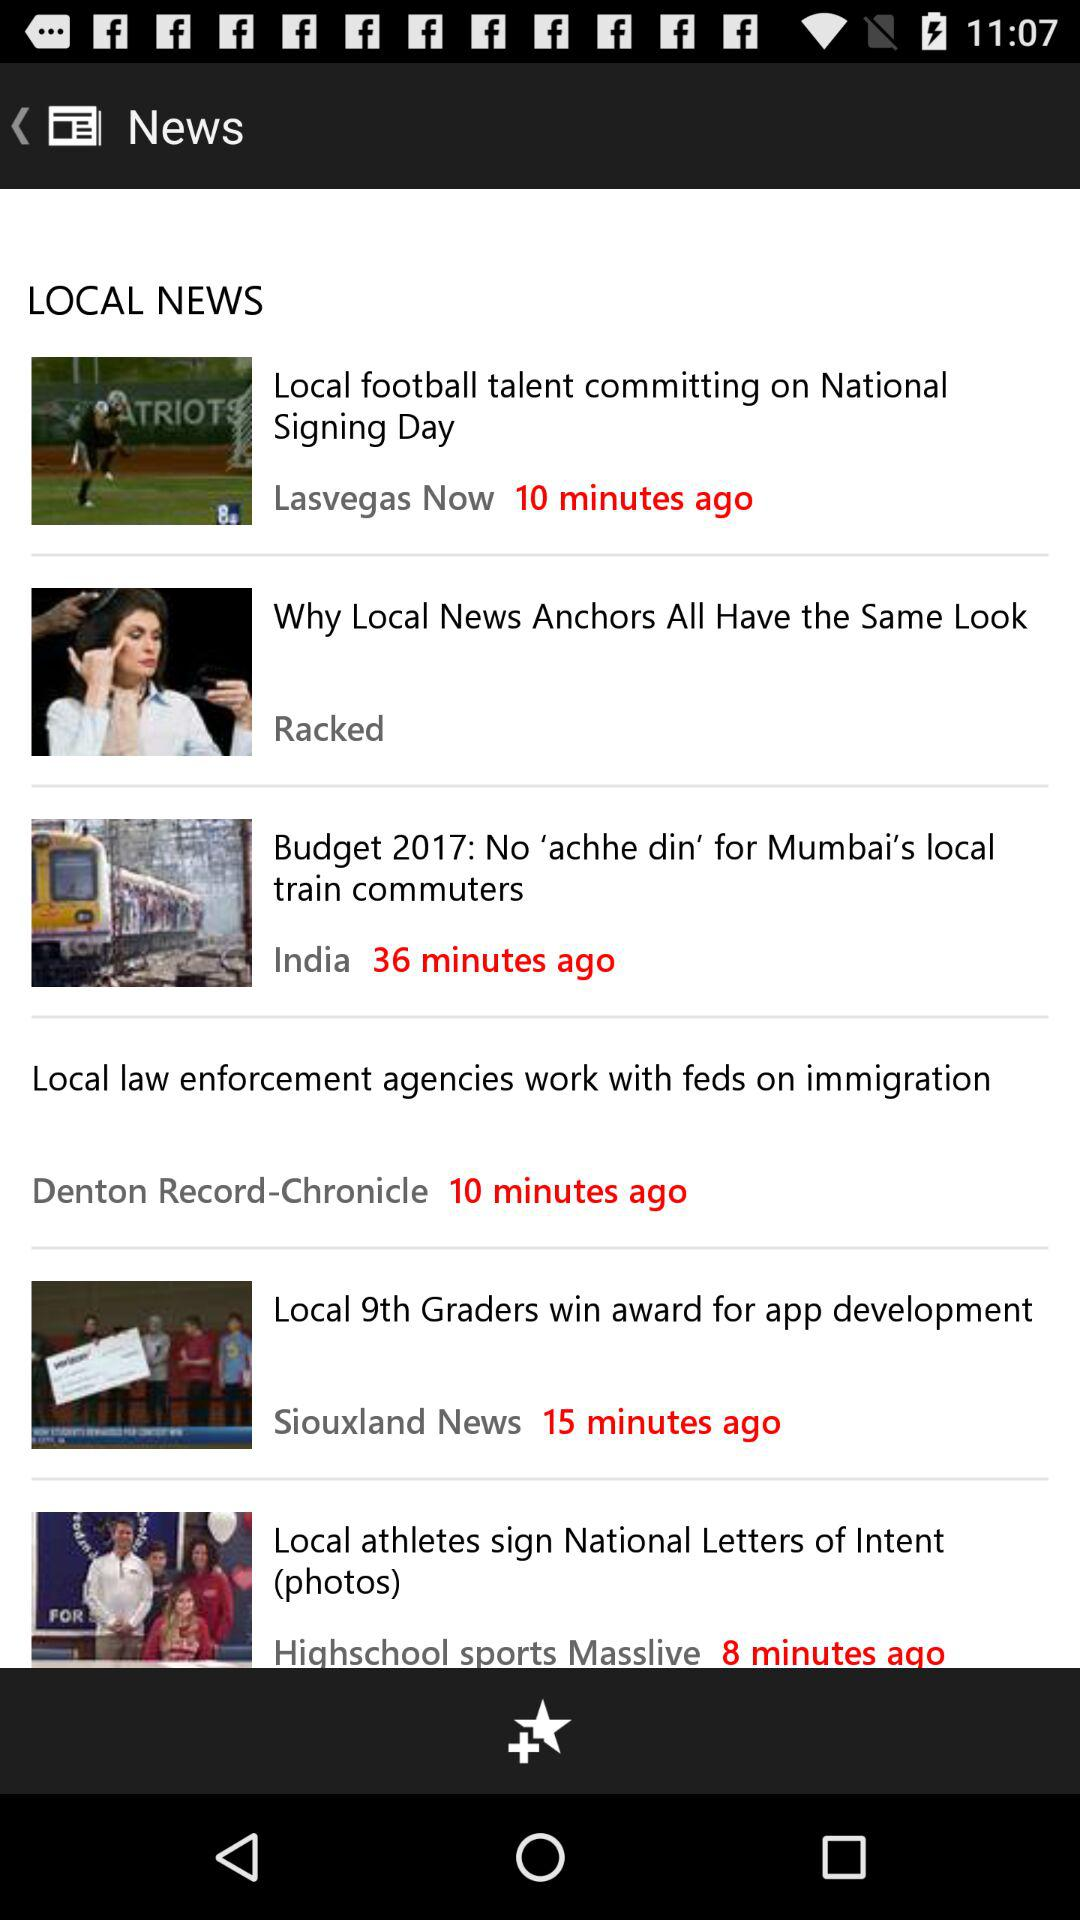When was the news on budget 2017 updated? The news on budget 2017 was updated 36 minutes ago. 